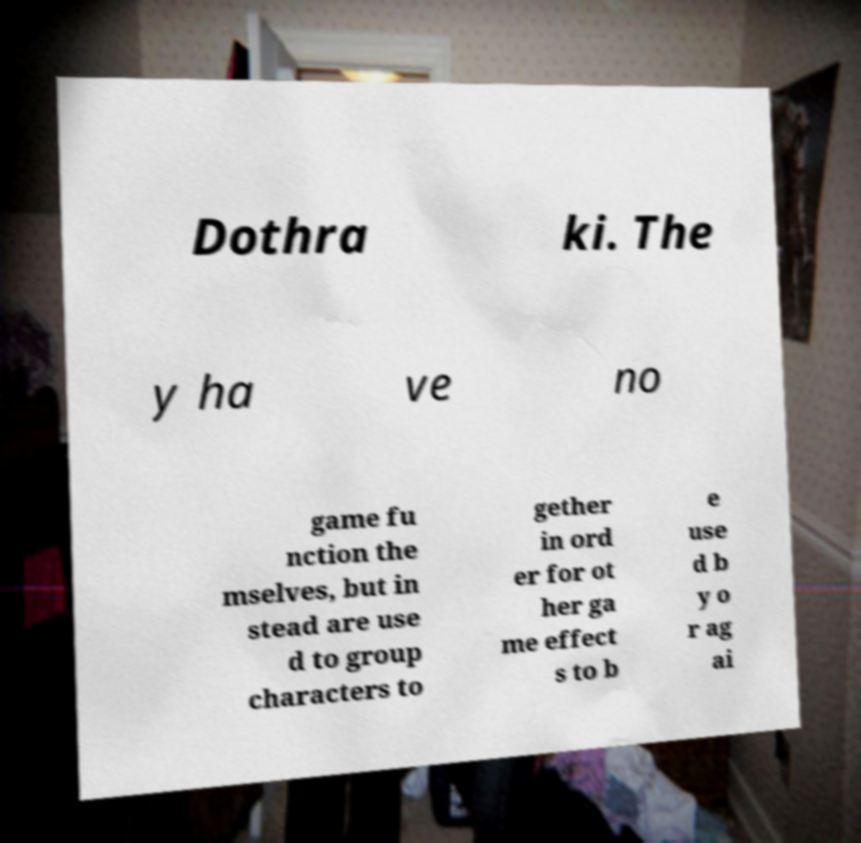Can you accurately transcribe the text from the provided image for me? Dothra ki. The y ha ve no game fu nction the mselves, but in stead are use d to group characters to gether in ord er for ot her ga me effect s to b e use d b y o r ag ai 